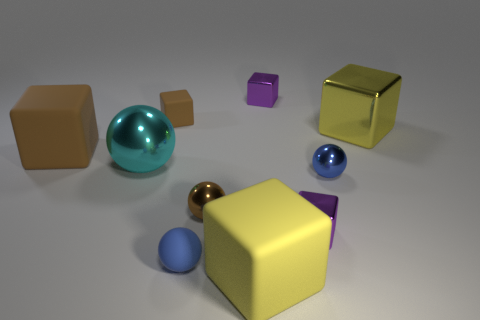Is there anything else that has the same size as the cyan sphere?
Your response must be concise. Yes. Does the blue thing that is right of the blue matte sphere have the same material as the large sphere?
Provide a short and direct response. Yes. There is a matte thing that is the same shape as the cyan metal object; what color is it?
Provide a short and direct response. Blue. What number of other things are the same color as the large shiny block?
Make the answer very short. 1. Do the big metallic object behind the big cyan shiny sphere and the big brown thing that is to the left of the tiny brown matte cube have the same shape?
Provide a short and direct response. Yes. How many spheres are either large brown objects or purple objects?
Provide a short and direct response. 0. Is the number of small blue matte balls to the left of the small blue rubber object less than the number of green metallic things?
Offer a terse response. No. What number of other things are there of the same material as the brown sphere
Your answer should be very brief. 5. Is the size of the yellow matte cube the same as the blue rubber object?
Provide a short and direct response. No. What number of things are either metallic objects that are to the right of the blue metallic ball or small brown blocks?
Your answer should be very brief. 2. 